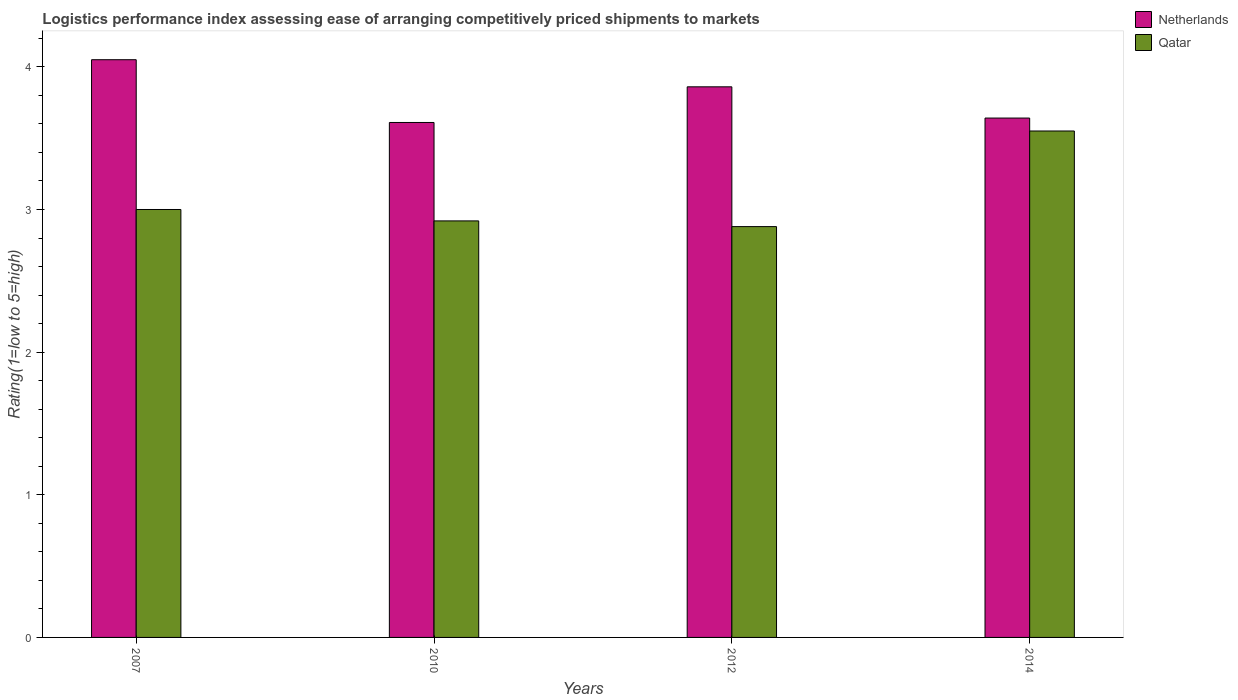How many different coloured bars are there?
Your answer should be very brief. 2. How many bars are there on the 1st tick from the left?
Your answer should be compact. 2. How many bars are there on the 1st tick from the right?
Provide a succinct answer. 2. What is the label of the 1st group of bars from the left?
Make the answer very short. 2007. What is the Logistic performance index in Netherlands in 2012?
Your response must be concise. 3.86. Across all years, what is the maximum Logistic performance index in Qatar?
Your response must be concise. 3.55. Across all years, what is the minimum Logistic performance index in Qatar?
Your answer should be compact. 2.88. In which year was the Logistic performance index in Netherlands maximum?
Provide a short and direct response. 2007. What is the total Logistic performance index in Netherlands in the graph?
Your answer should be very brief. 15.16. What is the difference between the Logistic performance index in Netherlands in 2007 and that in 2014?
Keep it short and to the point. 0.41. What is the difference between the Logistic performance index in Qatar in 2010 and the Logistic performance index in Netherlands in 2014?
Provide a short and direct response. -0.72. What is the average Logistic performance index in Qatar per year?
Give a very brief answer. 3.09. In the year 2007, what is the difference between the Logistic performance index in Qatar and Logistic performance index in Netherlands?
Your answer should be compact. -1.05. What is the ratio of the Logistic performance index in Qatar in 2007 to that in 2010?
Ensure brevity in your answer.  1.03. Is the Logistic performance index in Netherlands in 2007 less than that in 2014?
Ensure brevity in your answer.  No. Is the difference between the Logistic performance index in Qatar in 2007 and 2012 greater than the difference between the Logistic performance index in Netherlands in 2007 and 2012?
Your answer should be compact. No. What is the difference between the highest and the second highest Logistic performance index in Qatar?
Provide a succinct answer. 0.55. What is the difference between the highest and the lowest Logistic performance index in Netherlands?
Your response must be concise. 0.44. In how many years, is the Logistic performance index in Netherlands greater than the average Logistic performance index in Netherlands taken over all years?
Provide a succinct answer. 2. What does the 1st bar from the left in 2014 represents?
Keep it short and to the point. Netherlands. What does the 2nd bar from the right in 2012 represents?
Your answer should be compact. Netherlands. How many bars are there?
Ensure brevity in your answer.  8. How many years are there in the graph?
Offer a terse response. 4. Does the graph contain any zero values?
Your answer should be compact. No. Does the graph contain grids?
Make the answer very short. No. How many legend labels are there?
Offer a terse response. 2. What is the title of the graph?
Your answer should be compact. Logistics performance index assessing ease of arranging competitively priced shipments to markets. What is the label or title of the X-axis?
Your response must be concise. Years. What is the label or title of the Y-axis?
Ensure brevity in your answer.  Rating(1=low to 5=high). What is the Rating(1=low to 5=high) in Netherlands in 2007?
Your response must be concise. 4.05. What is the Rating(1=low to 5=high) of Netherlands in 2010?
Your answer should be compact. 3.61. What is the Rating(1=low to 5=high) in Qatar in 2010?
Provide a succinct answer. 2.92. What is the Rating(1=low to 5=high) in Netherlands in 2012?
Provide a short and direct response. 3.86. What is the Rating(1=low to 5=high) of Qatar in 2012?
Your answer should be very brief. 2.88. What is the Rating(1=low to 5=high) of Netherlands in 2014?
Your response must be concise. 3.64. What is the Rating(1=low to 5=high) in Qatar in 2014?
Your answer should be compact. 3.55. Across all years, what is the maximum Rating(1=low to 5=high) of Netherlands?
Make the answer very short. 4.05. Across all years, what is the maximum Rating(1=low to 5=high) of Qatar?
Your answer should be compact. 3.55. Across all years, what is the minimum Rating(1=low to 5=high) of Netherlands?
Offer a very short reply. 3.61. Across all years, what is the minimum Rating(1=low to 5=high) of Qatar?
Make the answer very short. 2.88. What is the total Rating(1=low to 5=high) of Netherlands in the graph?
Keep it short and to the point. 15.16. What is the total Rating(1=low to 5=high) of Qatar in the graph?
Keep it short and to the point. 12.35. What is the difference between the Rating(1=low to 5=high) of Netherlands in 2007 and that in 2010?
Your response must be concise. 0.44. What is the difference between the Rating(1=low to 5=high) in Netherlands in 2007 and that in 2012?
Offer a very short reply. 0.19. What is the difference between the Rating(1=low to 5=high) of Qatar in 2007 and that in 2012?
Your answer should be compact. 0.12. What is the difference between the Rating(1=low to 5=high) in Netherlands in 2007 and that in 2014?
Offer a very short reply. 0.41. What is the difference between the Rating(1=low to 5=high) in Qatar in 2007 and that in 2014?
Provide a short and direct response. -0.55. What is the difference between the Rating(1=low to 5=high) in Netherlands in 2010 and that in 2012?
Offer a terse response. -0.25. What is the difference between the Rating(1=low to 5=high) of Qatar in 2010 and that in 2012?
Your answer should be very brief. 0.04. What is the difference between the Rating(1=low to 5=high) in Netherlands in 2010 and that in 2014?
Keep it short and to the point. -0.03. What is the difference between the Rating(1=low to 5=high) in Qatar in 2010 and that in 2014?
Make the answer very short. -0.63. What is the difference between the Rating(1=low to 5=high) in Netherlands in 2012 and that in 2014?
Make the answer very short. 0.22. What is the difference between the Rating(1=low to 5=high) of Qatar in 2012 and that in 2014?
Give a very brief answer. -0.67. What is the difference between the Rating(1=low to 5=high) in Netherlands in 2007 and the Rating(1=low to 5=high) in Qatar in 2010?
Provide a short and direct response. 1.13. What is the difference between the Rating(1=low to 5=high) in Netherlands in 2007 and the Rating(1=low to 5=high) in Qatar in 2012?
Your answer should be very brief. 1.17. What is the difference between the Rating(1=low to 5=high) in Netherlands in 2007 and the Rating(1=low to 5=high) in Qatar in 2014?
Provide a succinct answer. 0.5. What is the difference between the Rating(1=low to 5=high) in Netherlands in 2010 and the Rating(1=low to 5=high) in Qatar in 2012?
Provide a short and direct response. 0.73. What is the difference between the Rating(1=low to 5=high) of Netherlands in 2010 and the Rating(1=low to 5=high) of Qatar in 2014?
Offer a very short reply. 0.06. What is the difference between the Rating(1=low to 5=high) in Netherlands in 2012 and the Rating(1=low to 5=high) in Qatar in 2014?
Your answer should be compact. 0.31. What is the average Rating(1=low to 5=high) of Netherlands per year?
Offer a terse response. 3.79. What is the average Rating(1=low to 5=high) in Qatar per year?
Offer a terse response. 3.09. In the year 2010, what is the difference between the Rating(1=low to 5=high) of Netherlands and Rating(1=low to 5=high) of Qatar?
Your answer should be very brief. 0.69. In the year 2012, what is the difference between the Rating(1=low to 5=high) in Netherlands and Rating(1=low to 5=high) in Qatar?
Keep it short and to the point. 0.98. In the year 2014, what is the difference between the Rating(1=low to 5=high) of Netherlands and Rating(1=low to 5=high) of Qatar?
Provide a short and direct response. 0.09. What is the ratio of the Rating(1=low to 5=high) in Netherlands in 2007 to that in 2010?
Make the answer very short. 1.12. What is the ratio of the Rating(1=low to 5=high) of Qatar in 2007 to that in 2010?
Offer a very short reply. 1.03. What is the ratio of the Rating(1=low to 5=high) of Netherlands in 2007 to that in 2012?
Your answer should be compact. 1.05. What is the ratio of the Rating(1=low to 5=high) in Qatar in 2007 to that in 2012?
Keep it short and to the point. 1.04. What is the ratio of the Rating(1=low to 5=high) in Netherlands in 2007 to that in 2014?
Your answer should be compact. 1.11. What is the ratio of the Rating(1=low to 5=high) of Qatar in 2007 to that in 2014?
Your answer should be very brief. 0.84. What is the ratio of the Rating(1=low to 5=high) in Netherlands in 2010 to that in 2012?
Your answer should be compact. 0.94. What is the ratio of the Rating(1=low to 5=high) of Qatar in 2010 to that in 2012?
Your response must be concise. 1.01. What is the ratio of the Rating(1=low to 5=high) in Netherlands in 2010 to that in 2014?
Ensure brevity in your answer.  0.99. What is the ratio of the Rating(1=low to 5=high) of Qatar in 2010 to that in 2014?
Offer a very short reply. 0.82. What is the ratio of the Rating(1=low to 5=high) of Netherlands in 2012 to that in 2014?
Provide a succinct answer. 1.06. What is the ratio of the Rating(1=low to 5=high) in Qatar in 2012 to that in 2014?
Provide a short and direct response. 0.81. What is the difference between the highest and the second highest Rating(1=low to 5=high) in Netherlands?
Make the answer very short. 0.19. What is the difference between the highest and the second highest Rating(1=low to 5=high) of Qatar?
Offer a terse response. 0.55. What is the difference between the highest and the lowest Rating(1=low to 5=high) of Netherlands?
Keep it short and to the point. 0.44. What is the difference between the highest and the lowest Rating(1=low to 5=high) in Qatar?
Make the answer very short. 0.67. 